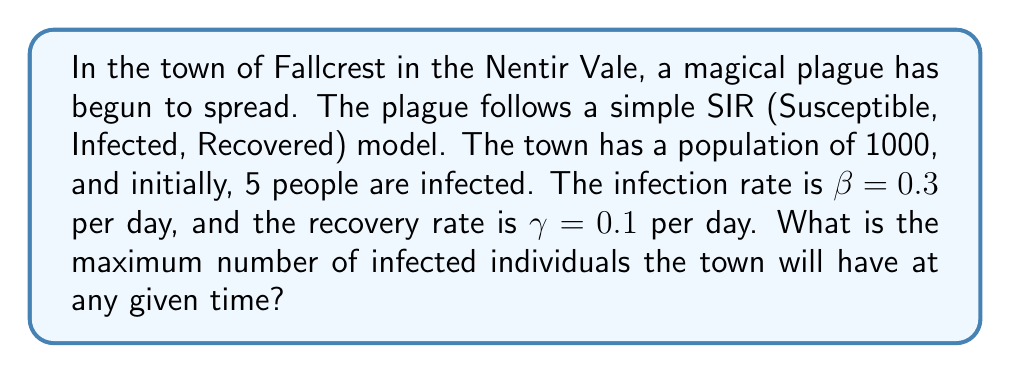Can you solve this math problem? To solve this problem, we'll use the SIR model equations and find the maximum number of infected individuals:

1. The SIR model equations are:
   $$\frac{dS}{dt} = -\beta SI$$
   $$\frac{dI}{dt} = \beta SI - \gamma I$$
   $$\frac{dR}{dt} = \gamma I$$

2. The maximum number of infected occurs when $\frac{dI}{dt} = 0$:
   $$0 = \beta SI - \gamma I$$
   $$\beta S = \gamma$$
   $$S = \frac{\gamma}{\beta}$$

3. Calculate S at the peak of infection:
   $$S = \frac{0.1}{0.3} = \frac{1}{3}$$

4. The total population N = S + I + R = 1000
   At the peak, S = 1/3 of the population = 1000/3 ≈ 333

5. The number of infected at the peak:
   $$I_{max} = N - S - R_0$$
   Where $R_0$ is the initial number of recovered (0 in this case)

6. Therefore:
   $$I_{max} = 1000 - 333 - 0 = 667$$
Answer: 667 infected individuals 